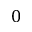<formula> <loc_0><loc_0><loc_500><loc_500>0</formula> 